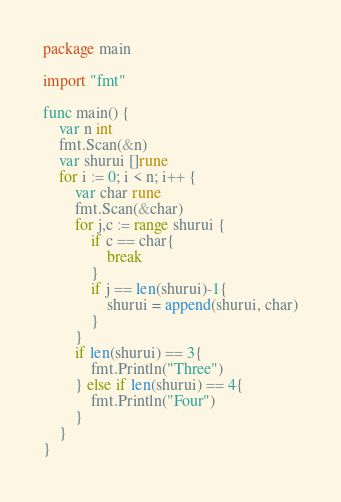<code> <loc_0><loc_0><loc_500><loc_500><_Go_>package main

import "fmt"

func main() {
	var n int
	fmt.Scan(&n)
	var shurui []rune
	for i := 0; i < n; i++ {
		var char rune
		fmt.Scan(&char)
		for j,c := range shurui {
			if c == char{
				break
			}
			if j == len(shurui)-1{
				shurui = append(shurui, char)
			} 
		}
		if len(shurui) == 3{
			fmt.Println("Three")
		} else if len(shurui) == 4{
			fmt.Println("Four")
		}
	}
}
</code> 